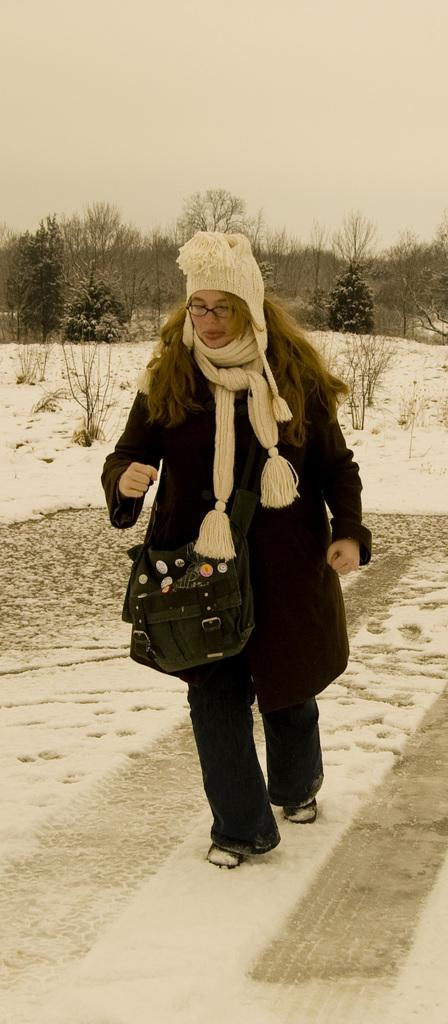What is the person in the image doing? There is a person walking in the image. What can be seen on the person's head? The person is wearing a white hat. What is visible in the background of the image? The sky, clouds, trees, and snow are present in the background of the image. What type of list is the person holding in the image? There is no list present in the image; the person is simply walking. Can you see a crow in the image? There is no crow present in the image. 